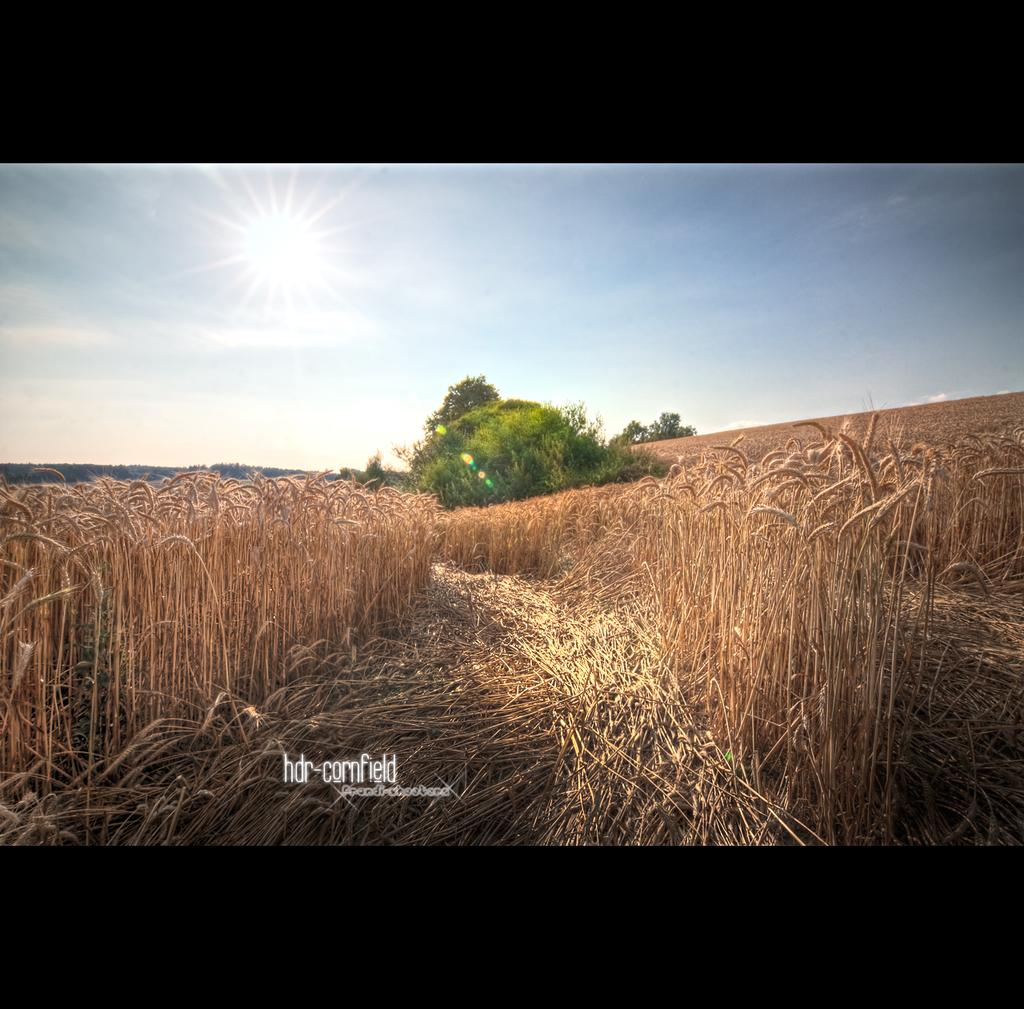What is the main feature in the center of the image? There are fields in the center of the image. What can be seen in the background of the image? There are trees in the background of the image. What is written at the bottom of the image? There is text written at the bottom of the image. What is visible in the sky at the top of the image? The sun is visible in the sky at the top of the image. What type of zinc can be seen in the fields in the image? There is no zinc present in the image; it features fields, trees, text, and the sun. What is the cannon used for in the image? There is no cannon present in the image. 